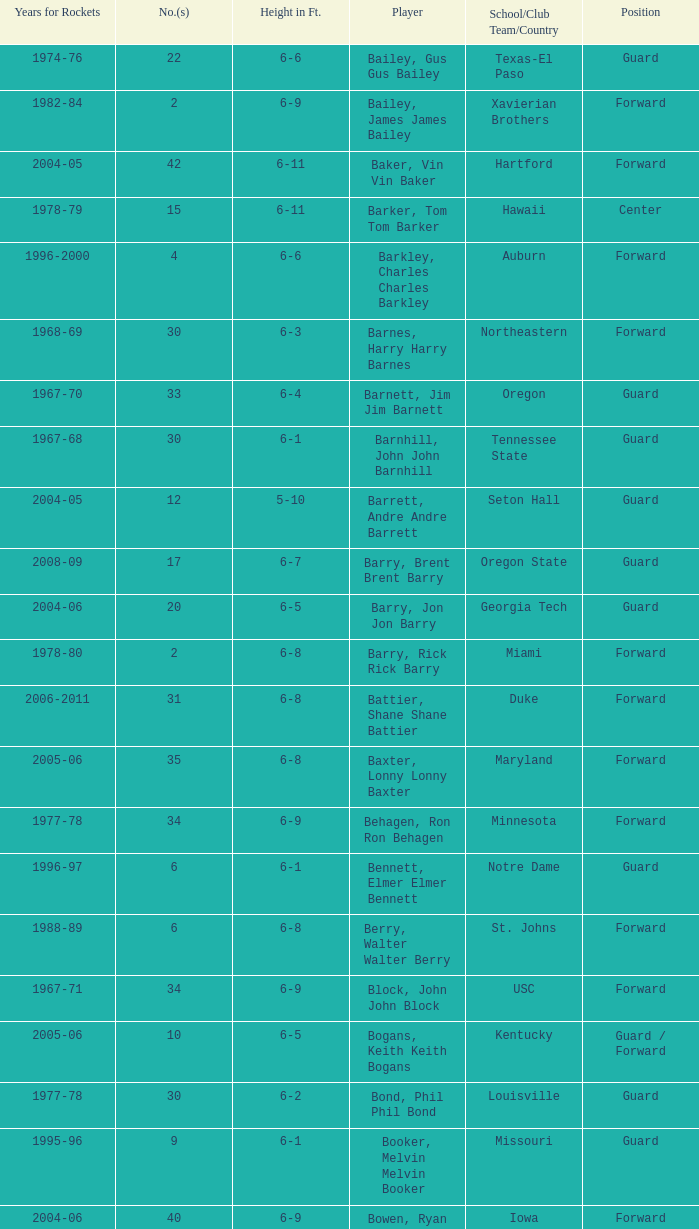What is the height of the player who attended Hartford? 6-11. 